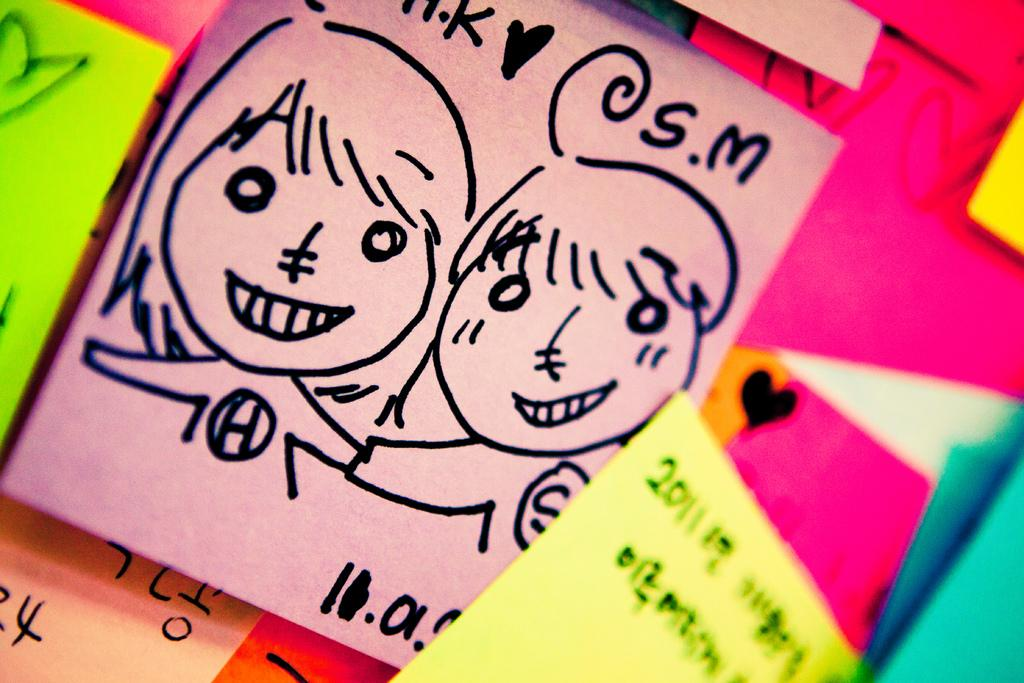What is on the wall in the image? There are papers on the wall in the image. What is the main subject in the center of the image? There is a design of a woman in the center of the image. How many sheets are visible on the wall in the image? There is no mention of sheets in the image; it features papers on the wall. Can you see any stamps on the design of the woman in the image? There is no mention of stamps in the image; it features a design of a woman. Are there any flies visible in the image? There is no mention of flies in the image. 